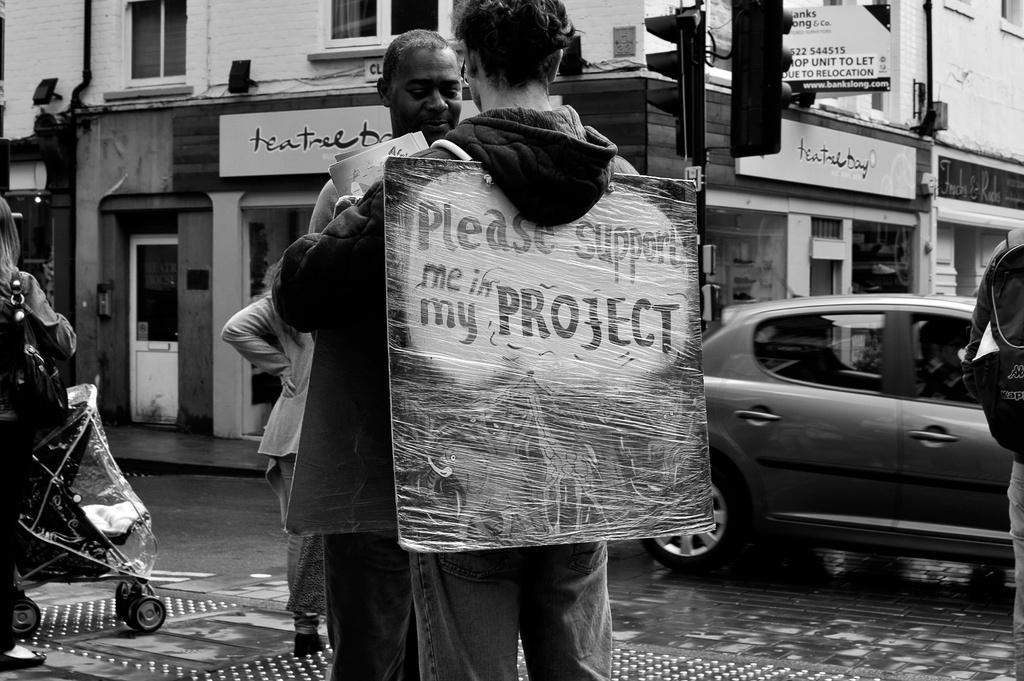Please provide a concise description of this image. This picture is in black and white. In the center, there are two men facing each other. On one of the person, there is a board with some text. Towards the left, there is a woman carrying a bag and holding a baby vehicle. Towards the right, there is a car. In the background, there are buildings, poles, signal lights etc. 